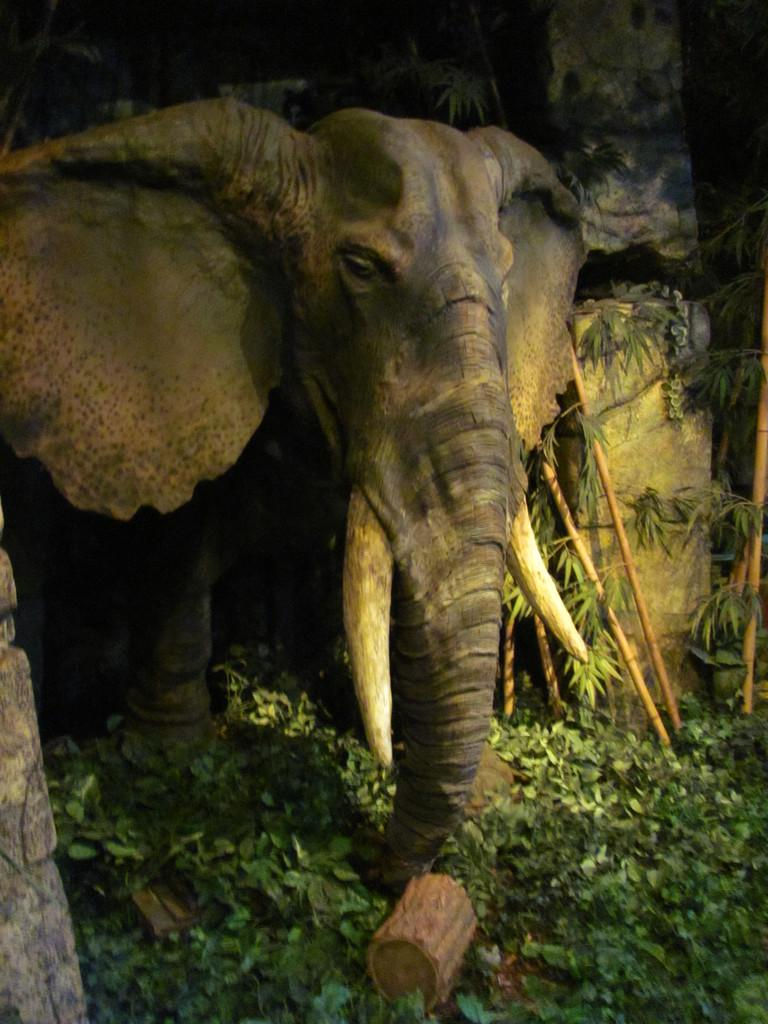What animal is the main subject of the image? There is an elephant in the image. What is the elephant doing with its trunk? The elephant is holding a log of wood with its trunk. What type of vegetation can be seen in the image? There are plants on the surface in the image. Where is the crate located in the image? There is no crate present in the image. What level of experience does the beginner have in the image? There is no indication of any person's experience level in the image. 